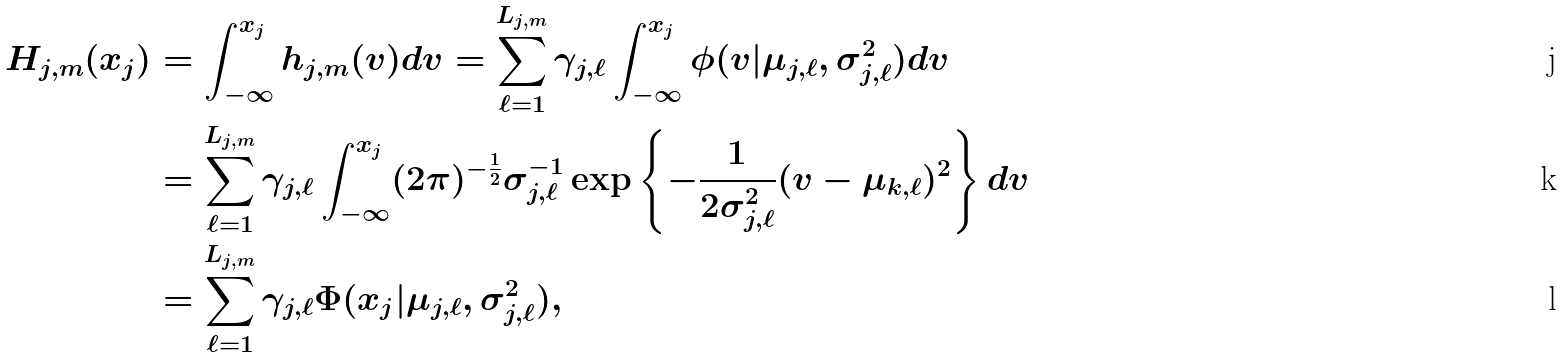<formula> <loc_0><loc_0><loc_500><loc_500>H _ { j , m } ( x _ { j } ) & = \int _ { - \infty } ^ { x _ { j } } h _ { j , m } ( v ) d v = \sum _ { \ell = 1 } ^ { L _ { j , m } } \gamma _ { j , \ell } \int _ { - \infty } ^ { x _ { j } } \phi ( v | \mu _ { j , \ell } , \sigma _ { j , \ell } ^ { 2 } ) d v \\ & = \sum _ { \ell = 1 } ^ { L _ { j , m } } \gamma _ { j , \ell } \int _ { - \infty } ^ { x _ { j } } ( 2 \pi ) ^ { - \frac { 1 } { 2 } } \sigma _ { j , \ell } ^ { - 1 } \exp \left \{ - \frac { 1 } { 2 \sigma _ { j , \ell } ^ { 2 } } ( v - \mu _ { k , \ell } ) ^ { 2 } \right \} d v \\ & = \sum _ { \ell = 1 } ^ { L _ { j , m } } \gamma _ { j , \ell } \Phi ( x _ { j } | \mu _ { j , \ell } , \sigma _ { j , \ell } ^ { 2 } ) ,</formula> 